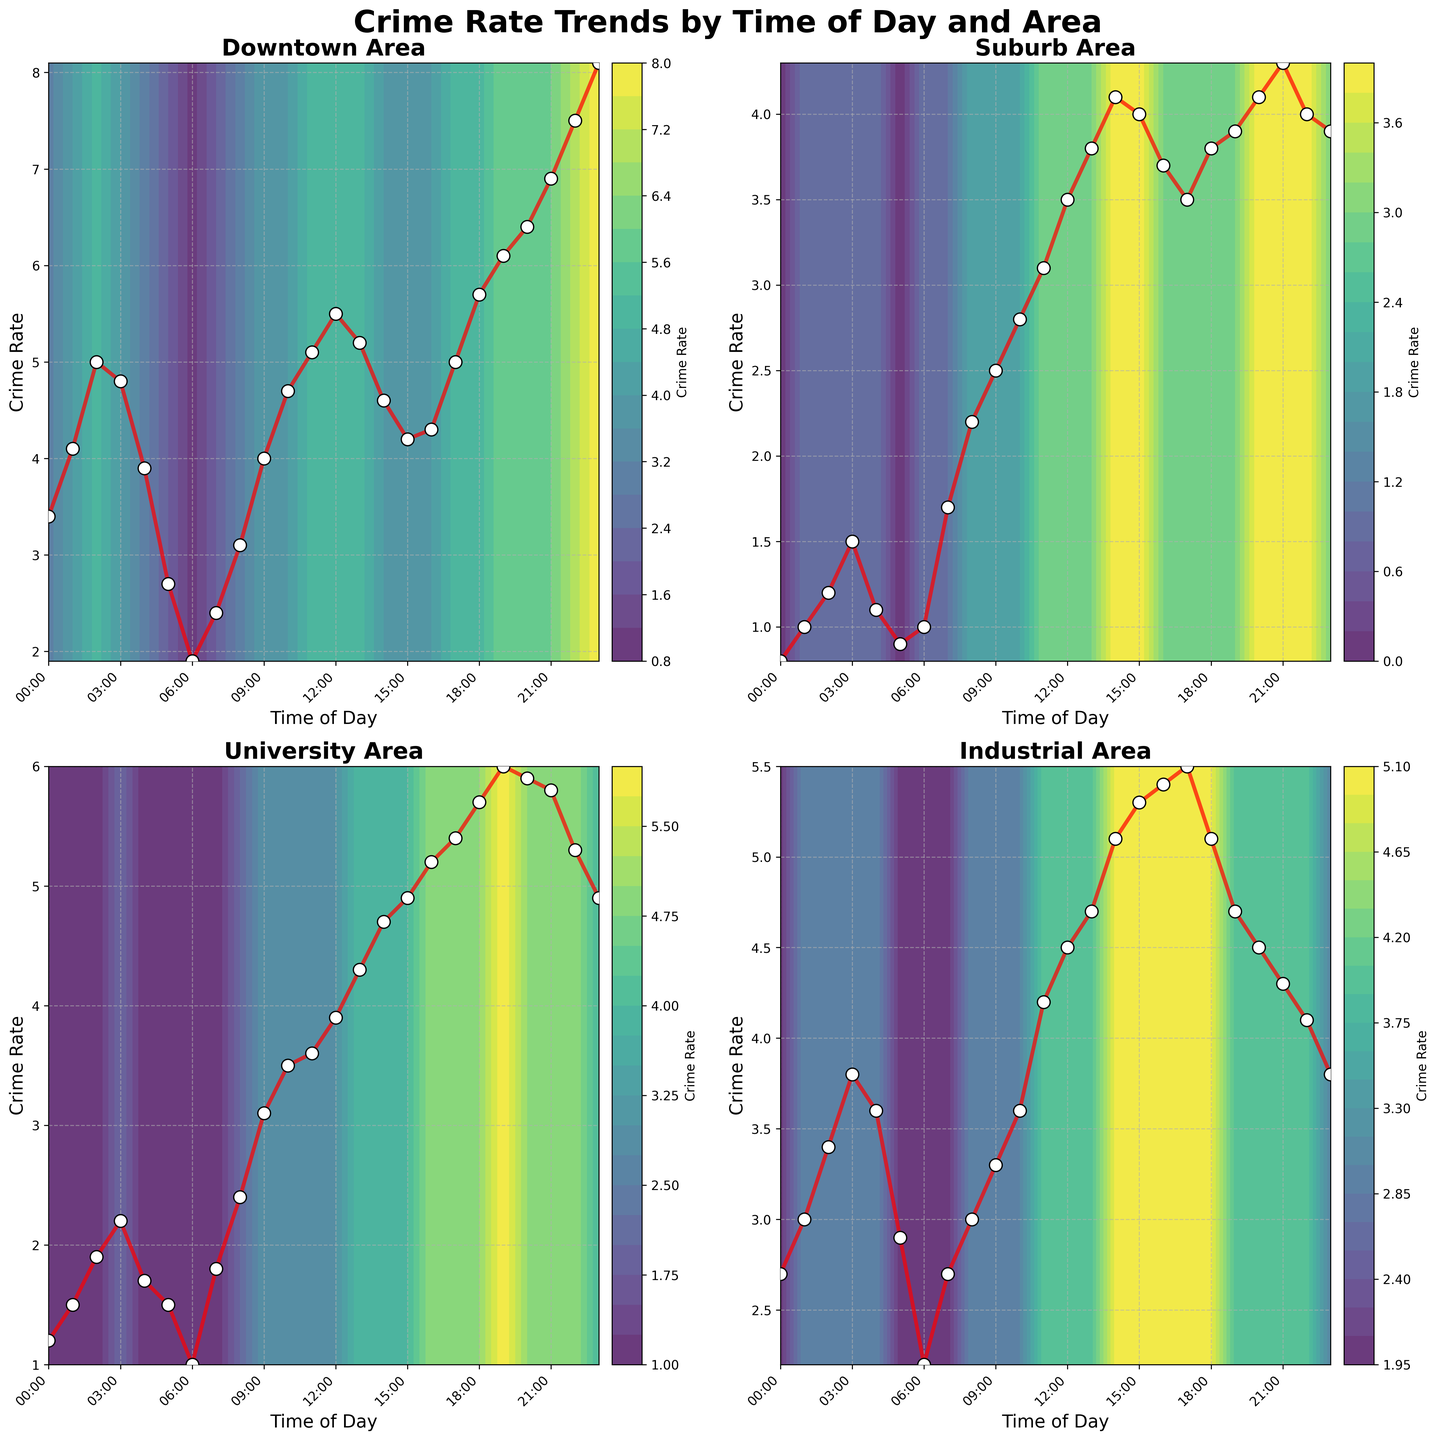What is the title of the figure? The title is usually displayed prominently at the top of the figure. In this case, it is 'Crime Rate Trends by Time of Day and Area', explaining the focus of the plot.
Answer: Crime Rate Trends by Time of Day and Area How are the different areas represented in the figure? The figure uses four subplots, each representing a different area: Downtown, Suburb, University, and Industrial. Each subplot is titled accordingly.
Answer: Four subplots: Downtown, Suburb, University, Industrial Which area has the highest crime rate peak and at what time does it occur? By examining the subplots, the contour lines, and the red trend lines, Downtown has the highest peak indicated by the plot reaching 8.1 at 23:00.
Answer: Downtown at 23:00 What time of day generally has the lowest crime rate in Downtown? Checking the contour levels and the red trend line in the Downtown subplot, the lowest point is around 06:00 with a crime rate of 1.9.
Answer: 06:00 Compare the crime rate trends during the evening (18:00 to 23:00) between Suburb and University areas. Which area has a higher overall crime rate during this time? Observation shows that University consistently has higher crime rates than Suburb during the evening hours, with values ranging from 5.7 to 4.9, whereas Suburb ranges from 3.8 to 3.9.
Answer: University In which area does the crime rate show the most significant increase from early morning (06:00) to late night (23:00)? By comparing the starting and ending crime rates in each subplot, Downtown shows the most significant increase from 1.9 to 8.1.
Answer: Downtown Which area shows a relatively stable crime rate throughout the day? The Suburb area shows relatively minor fluctuations in its crime rate throughout the day compared to the other areas, indicated by consistently tight contour lines and a relatively flat red trend line.
Answer: Suburb What is the crime rate in the Industrial area at 15:00? By checking the x-axis for 15:00 and the corresponding point on the red line in the Industrial subplot, the crime rate at that time is noted as 5.3.
Answer: 5.3 Compare the early morning (00:00 to 06:00) crime rates between University and Industrial areas. Which one has higher values in this period? Observing the trends in both subplots, the University area has relatively higher crime rates (1.2 to 2.2) compared to the Industrial area (2.7 to 3.8) in the early morning.
Answer: Industrial How does the crime rate change in the Suburb area from noon (12:00) to the afternoon (16:00)? Examining the red trend line and values in the Suburb subplot, the crime rate increases from 3.5 at 12:00 to a peak of 4.1 at 14:00, then slightly decreases to 3.7 at 16:00.
Answer: Increases, then decreases 